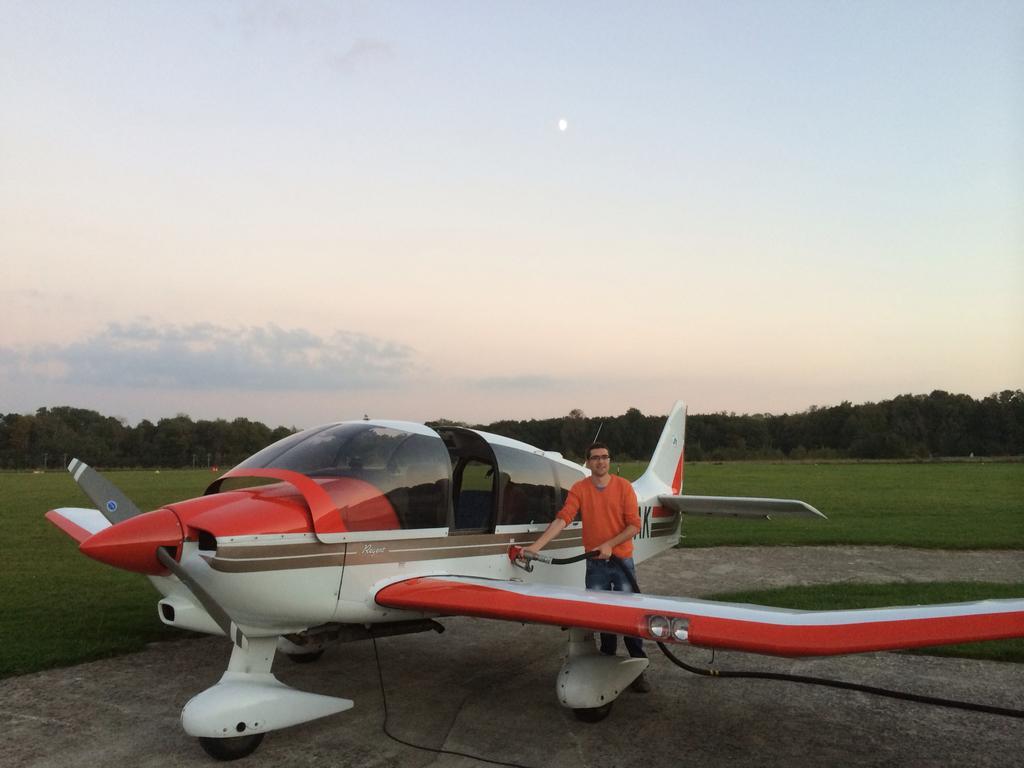Can you describe this image briefly? In this image we can see an aeroplane and a person standing beside the aeroplane on the floor and holding a pipeline in his hands. In the background we can see ground, trees and sky with clouds. 